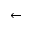<formula> <loc_0><loc_0><loc_500><loc_500>\leftarrow</formula> 